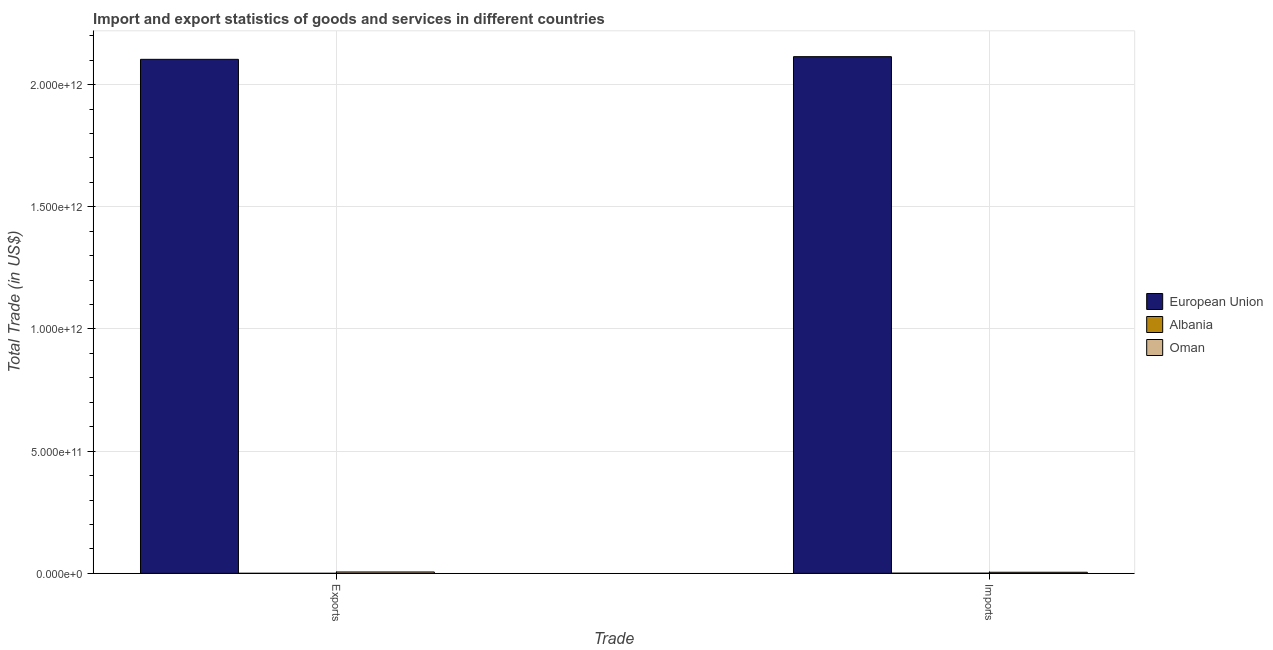How many different coloured bars are there?
Provide a succinct answer. 3. Are the number of bars per tick equal to the number of legend labels?
Provide a short and direct response. Yes. How many bars are there on the 1st tick from the left?
Ensure brevity in your answer.  3. How many bars are there on the 1st tick from the right?
Offer a terse response. 3. What is the label of the 2nd group of bars from the left?
Make the answer very short. Imports. What is the imports of goods and services in Albania?
Keep it short and to the point. 6.28e+08. Across all countries, what is the maximum imports of goods and services?
Your answer should be very brief. 2.11e+12. Across all countries, what is the minimum imports of goods and services?
Keep it short and to the point. 6.28e+08. In which country was the export of goods and services minimum?
Give a very brief answer. Albania. What is the total imports of goods and services in the graph?
Your answer should be very brief. 2.12e+12. What is the difference between the export of goods and services in European Union and that in Oman?
Give a very brief answer. 2.10e+12. What is the difference between the export of goods and services in Oman and the imports of goods and services in Albania?
Provide a short and direct response. 4.94e+09. What is the average export of goods and services per country?
Your response must be concise. 7.03e+11. What is the difference between the imports of goods and services and export of goods and services in Oman?
Ensure brevity in your answer.  -1.14e+09. In how many countries, is the imports of goods and services greater than 1800000000000 US$?
Your response must be concise. 1. What is the ratio of the imports of goods and services in Albania to that in European Union?
Keep it short and to the point. 0. What does the 1st bar from the right in Imports represents?
Offer a terse response. Oman. What is the difference between two consecutive major ticks on the Y-axis?
Give a very brief answer. 5.00e+11. Where does the legend appear in the graph?
Provide a succinct answer. Center right. How many legend labels are there?
Provide a short and direct response. 3. What is the title of the graph?
Provide a succinct answer. Import and export statistics of goods and services in different countries. Does "Nepal" appear as one of the legend labels in the graph?
Offer a terse response. No. What is the label or title of the X-axis?
Your answer should be very brief. Trade. What is the label or title of the Y-axis?
Provide a short and direct response. Total Trade (in US$). What is the Total Trade (in US$) in European Union in Exports?
Offer a terse response. 2.10e+12. What is the Total Trade (in US$) of Albania in Exports?
Provide a short and direct response. 8.15e+07. What is the Total Trade (in US$) in Oman in Exports?
Give a very brief answer. 5.57e+09. What is the Total Trade (in US$) in European Union in Imports?
Your answer should be very brief. 2.11e+12. What is the Total Trade (in US$) in Albania in Imports?
Your answer should be compact. 6.28e+08. What is the Total Trade (in US$) in Oman in Imports?
Offer a terse response. 4.43e+09. Across all Trade, what is the maximum Total Trade (in US$) of European Union?
Give a very brief answer. 2.11e+12. Across all Trade, what is the maximum Total Trade (in US$) of Albania?
Ensure brevity in your answer.  6.28e+08. Across all Trade, what is the maximum Total Trade (in US$) in Oman?
Your response must be concise. 5.57e+09. Across all Trade, what is the minimum Total Trade (in US$) of European Union?
Provide a succinct answer. 2.10e+12. Across all Trade, what is the minimum Total Trade (in US$) of Albania?
Your answer should be compact. 8.15e+07. Across all Trade, what is the minimum Total Trade (in US$) in Oman?
Your answer should be compact. 4.43e+09. What is the total Total Trade (in US$) in European Union in the graph?
Your answer should be very brief. 4.22e+12. What is the total Total Trade (in US$) of Albania in the graph?
Your answer should be very brief. 7.09e+08. What is the total Total Trade (in US$) of Oman in the graph?
Offer a terse response. 9.99e+09. What is the difference between the Total Trade (in US$) of European Union in Exports and that in Imports?
Give a very brief answer. -1.10e+1. What is the difference between the Total Trade (in US$) of Albania in Exports and that in Imports?
Ensure brevity in your answer.  -5.46e+08. What is the difference between the Total Trade (in US$) in Oman in Exports and that in Imports?
Give a very brief answer. 1.14e+09. What is the difference between the Total Trade (in US$) of European Union in Exports and the Total Trade (in US$) of Albania in Imports?
Provide a succinct answer. 2.10e+12. What is the difference between the Total Trade (in US$) in European Union in Exports and the Total Trade (in US$) in Oman in Imports?
Ensure brevity in your answer.  2.10e+12. What is the difference between the Total Trade (in US$) of Albania in Exports and the Total Trade (in US$) of Oman in Imports?
Ensure brevity in your answer.  -4.35e+09. What is the average Total Trade (in US$) of European Union per Trade?
Offer a very short reply. 2.11e+12. What is the average Total Trade (in US$) of Albania per Trade?
Keep it short and to the point. 3.55e+08. What is the average Total Trade (in US$) in Oman per Trade?
Give a very brief answer. 5.00e+09. What is the difference between the Total Trade (in US$) in European Union and Total Trade (in US$) in Albania in Exports?
Give a very brief answer. 2.10e+12. What is the difference between the Total Trade (in US$) in European Union and Total Trade (in US$) in Oman in Exports?
Make the answer very short. 2.10e+12. What is the difference between the Total Trade (in US$) in Albania and Total Trade (in US$) in Oman in Exports?
Provide a succinct answer. -5.49e+09. What is the difference between the Total Trade (in US$) in European Union and Total Trade (in US$) in Albania in Imports?
Provide a short and direct response. 2.11e+12. What is the difference between the Total Trade (in US$) of European Union and Total Trade (in US$) of Oman in Imports?
Make the answer very short. 2.11e+12. What is the difference between the Total Trade (in US$) in Albania and Total Trade (in US$) in Oman in Imports?
Keep it short and to the point. -3.80e+09. What is the ratio of the Total Trade (in US$) of European Union in Exports to that in Imports?
Make the answer very short. 0.99. What is the ratio of the Total Trade (in US$) of Albania in Exports to that in Imports?
Keep it short and to the point. 0.13. What is the ratio of the Total Trade (in US$) of Oman in Exports to that in Imports?
Your answer should be compact. 1.26. What is the difference between the highest and the second highest Total Trade (in US$) of European Union?
Provide a succinct answer. 1.10e+1. What is the difference between the highest and the second highest Total Trade (in US$) in Albania?
Your answer should be very brief. 5.46e+08. What is the difference between the highest and the second highest Total Trade (in US$) in Oman?
Make the answer very short. 1.14e+09. What is the difference between the highest and the lowest Total Trade (in US$) of European Union?
Offer a terse response. 1.10e+1. What is the difference between the highest and the lowest Total Trade (in US$) of Albania?
Your answer should be very brief. 5.46e+08. What is the difference between the highest and the lowest Total Trade (in US$) in Oman?
Provide a short and direct response. 1.14e+09. 